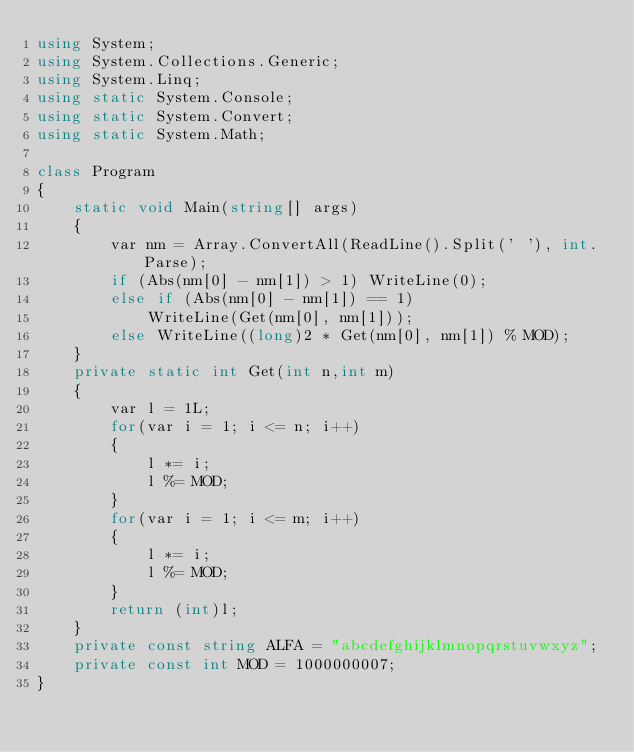Convert code to text. <code><loc_0><loc_0><loc_500><loc_500><_C#_>using System;
using System.Collections.Generic;
using System.Linq;
using static System.Console;
using static System.Convert;
using static System.Math;

class Program
{
    static void Main(string[] args)
    {
        var nm = Array.ConvertAll(ReadLine().Split(' '), int.Parse);
        if (Abs(nm[0] - nm[1]) > 1) WriteLine(0);
        else if (Abs(nm[0] - nm[1]) == 1)
            WriteLine(Get(nm[0], nm[1]));
        else WriteLine((long)2 * Get(nm[0], nm[1]) % MOD);
    }
    private static int Get(int n,int m)
    {
        var l = 1L;
        for(var i = 1; i <= n; i++)
        {
            l *= i;
            l %= MOD;
        }
        for(var i = 1; i <= m; i++)
        {
            l *= i;
            l %= MOD;
        }
        return (int)l;
    }
    private const string ALFA = "abcdefghijklmnopqrstuvwxyz";
    private const int MOD = 1000000007;
}
</code> 